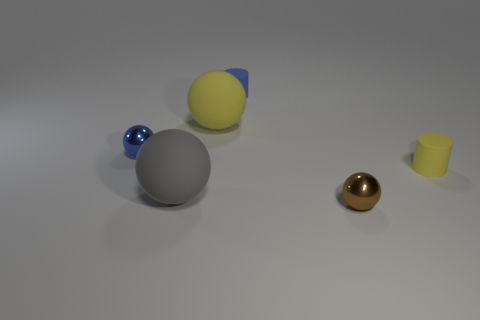How many things are tiny objects left of the big yellow sphere or spheres that are to the left of the brown metal sphere?
Give a very brief answer. 3. Are there more spheres that are behind the small yellow rubber thing than small yellow matte cylinders left of the yellow rubber sphere?
Make the answer very short. Yes. What number of spheres are blue matte objects or brown shiny objects?
Keep it short and to the point. 1. How many things are cylinders in front of the tiny blue matte cylinder or blue metallic things?
Offer a very short reply. 2. There is a yellow object that is in front of the small blue thing that is on the left side of the large yellow thing that is behind the brown shiny sphere; what shape is it?
Your answer should be very brief. Cylinder. What number of gray matte things have the same shape as the tiny brown shiny object?
Keep it short and to the point. 1. Are the yellow sphere and the tiny blue cylinder made of the same material?
Make the answer very short. Yes. There is a tiny matte cylinder to the left of the tiny shiny object right of the large gray rubber object; what number of big yellow rubber things are behind it?
Ensure brevity in your answer.  0. Is there a blue cylinder made of the same material as the large yellow sphere?
Make the answer very short. Yes. Is the number of big yellow things less than the number of big green metallic cubes?
Your response must be concise. No. 